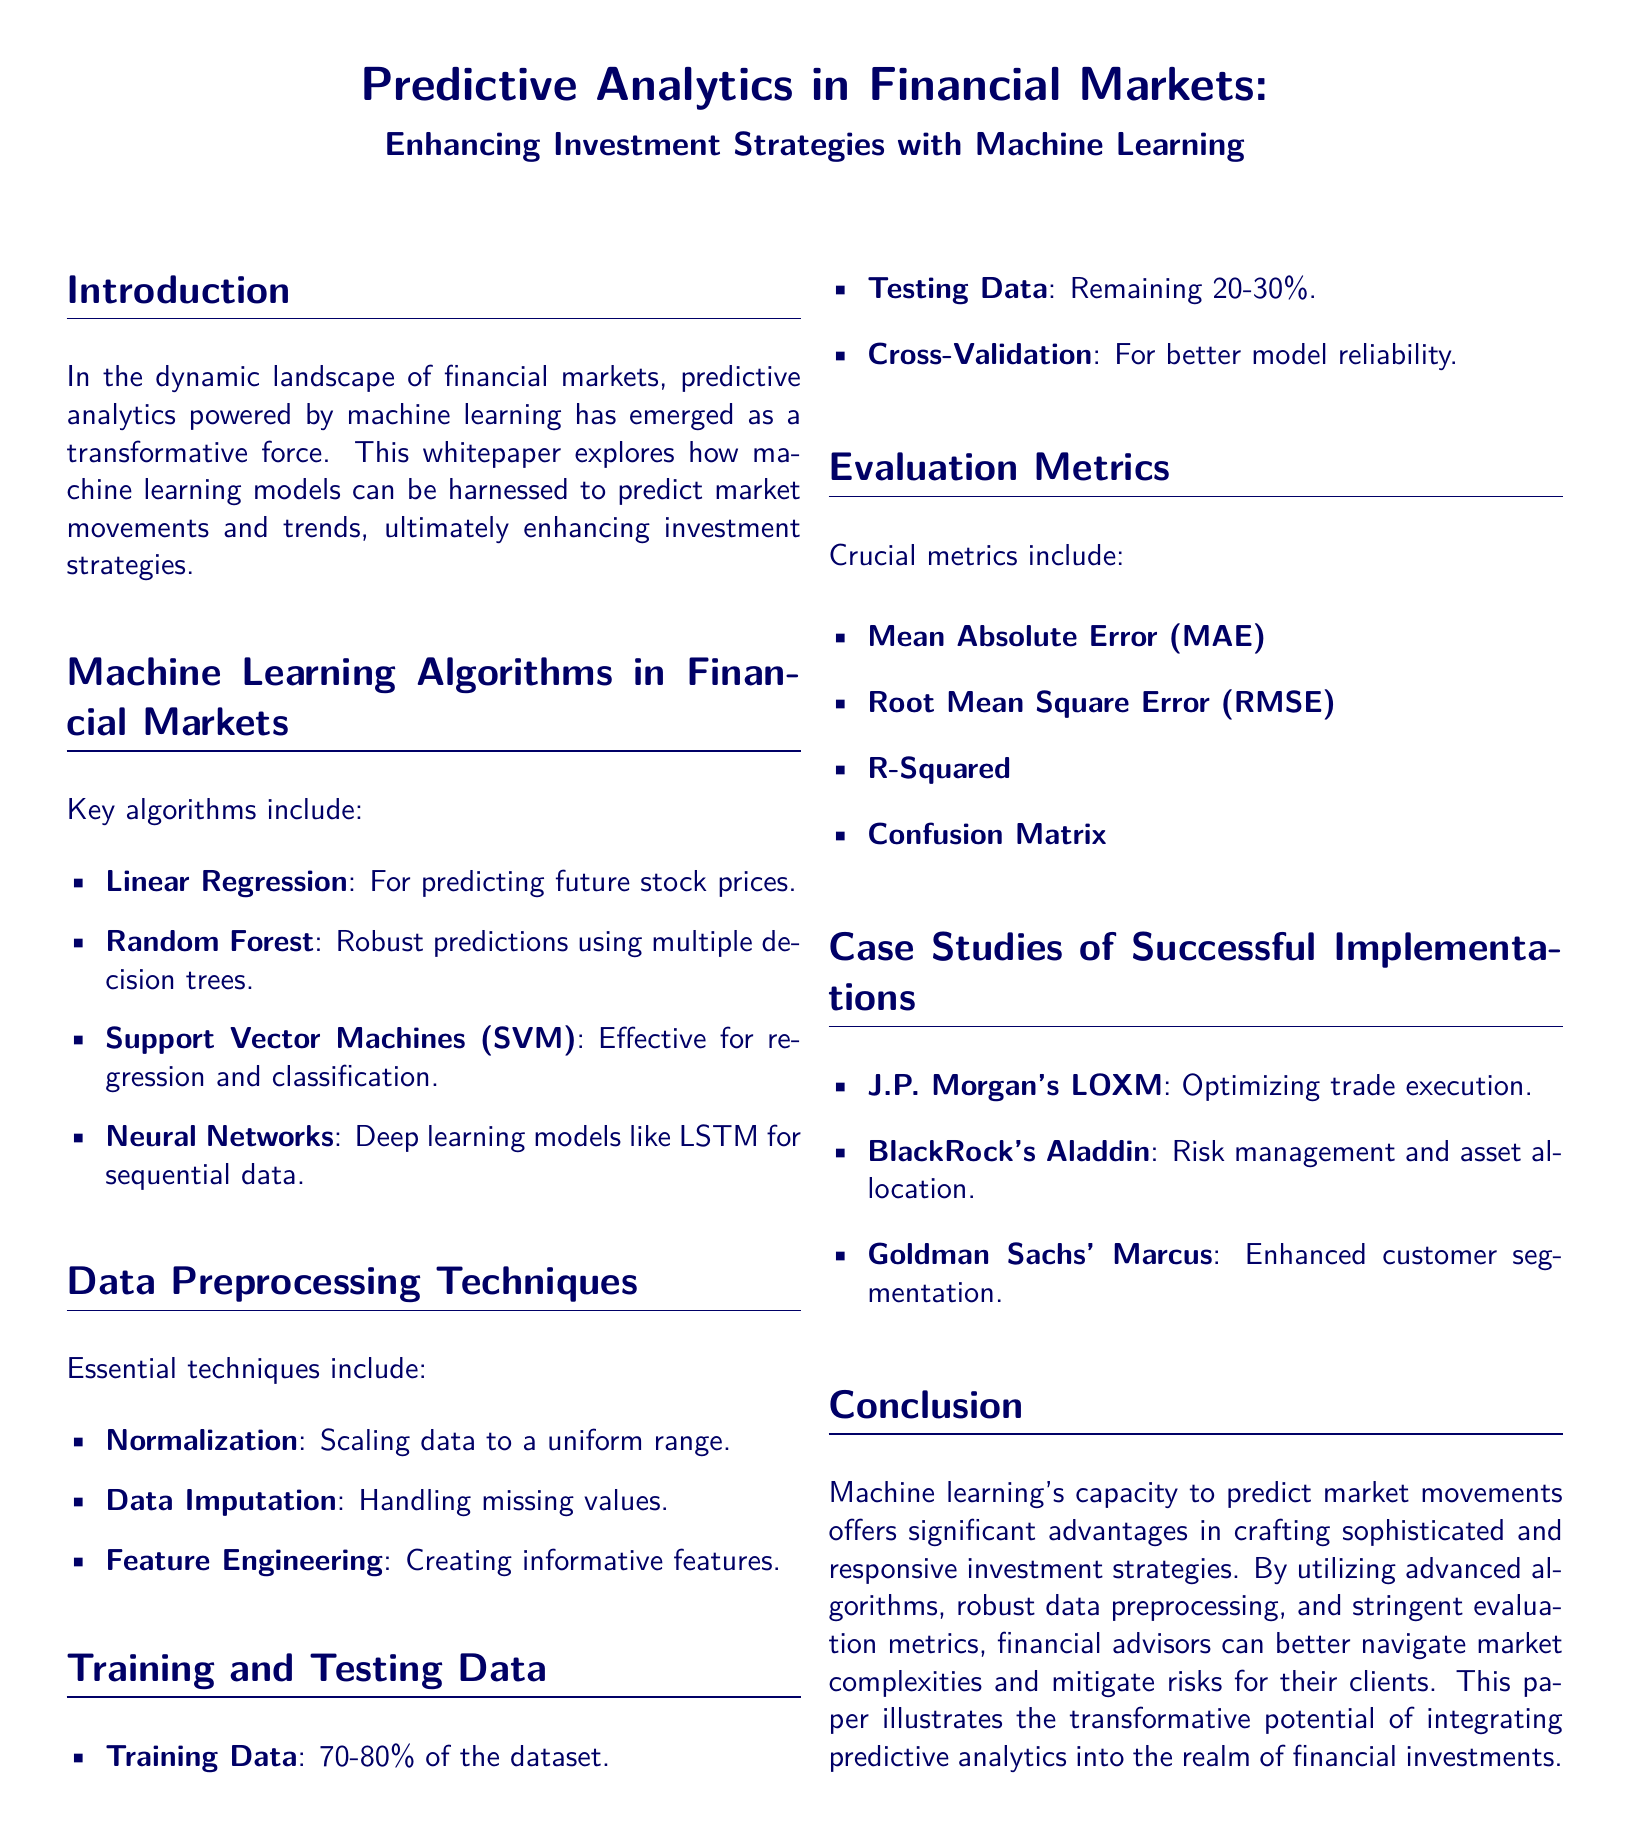What is the main focus of the whitepaper? The whitepaper explores how machine learning models can be harnessed to predict market movements and trends.
Answer: Predictive analytics powered by machine learning Which machine learning algorithm is mentioned for predicting future stock prices? The whitepaper lists Linear Regression as the algorithm for predicting future stock prices.
Answer: Linear Regression What percentage of the dataset is typically used for training data? The document states that 70-80% of the dataset is used as training data.
Answer: 70-80% What evaluation metric is referred to as MAE? MAE stands for Mean Absolute Error, as defined in the evaluation metrics section.
Answer: Mean Absolute Error Which case study is associated with optimizing trade execution? The case study of J.P. Morgan's LOXM is linked to optimizing trade execution.
Answer: J.P. Morgan's LOXM What is a key preprocessing technique mentioned in the document? Normalization is highlighted as an essential data preprocessing technique in the document.
Answer: Normalization Which financial institution's case study focuses on risk management? BlackRock's Aladdin is the case study that focuses on risk management and asset allocation.
Answer: BlackRock's Aladdin What is the purpose of cross-validation in machine learning? Cross-validation is described as a method for better model reliability in the training and testing data section.
Answer: Better model reliability What conclusion does the whitepaper draw about machine learning in financial markets? The conclusion emphasizes that machine learning's capacity to predict market movements offers significant advantages in crafting sophisticated and responsive investment strategies.
Answer: Significant advantages in crafting sophisticated and responsive investment strategies 